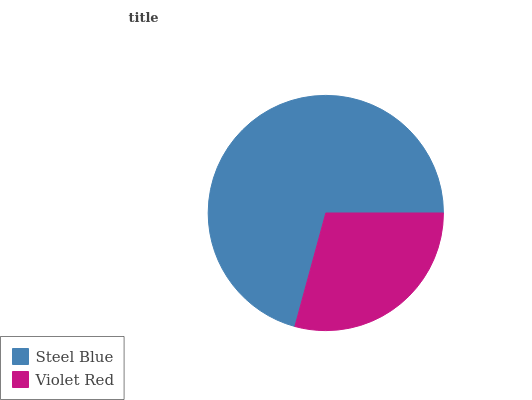Is Violet Red the minimum?
Answer yes or no. Yes. Is Steel Blue the maximum?
Answer yes or no. Yes. Is Violet Red the maximum?
Answer yes or no. No. Is Steel Blue greater than Violet Red?
Answer yes or no. Yes. Is Violet Red less than Steel Blue?
Answer yes or no. Yes. Is Violet Red greater than Steel Blue?
Answer yes or no. No. Is Steel Blue less than Violet Red?
Answer yes or no. No. Is Steel Blue the high median?
Answer yes or no. Yes. Is Violet Red the low median?
Answer yes or no. Yes. Is Violet Red the high median?
Answer yes or no. No. Is Steel Blue the low median?
Answer yes or no. No. 